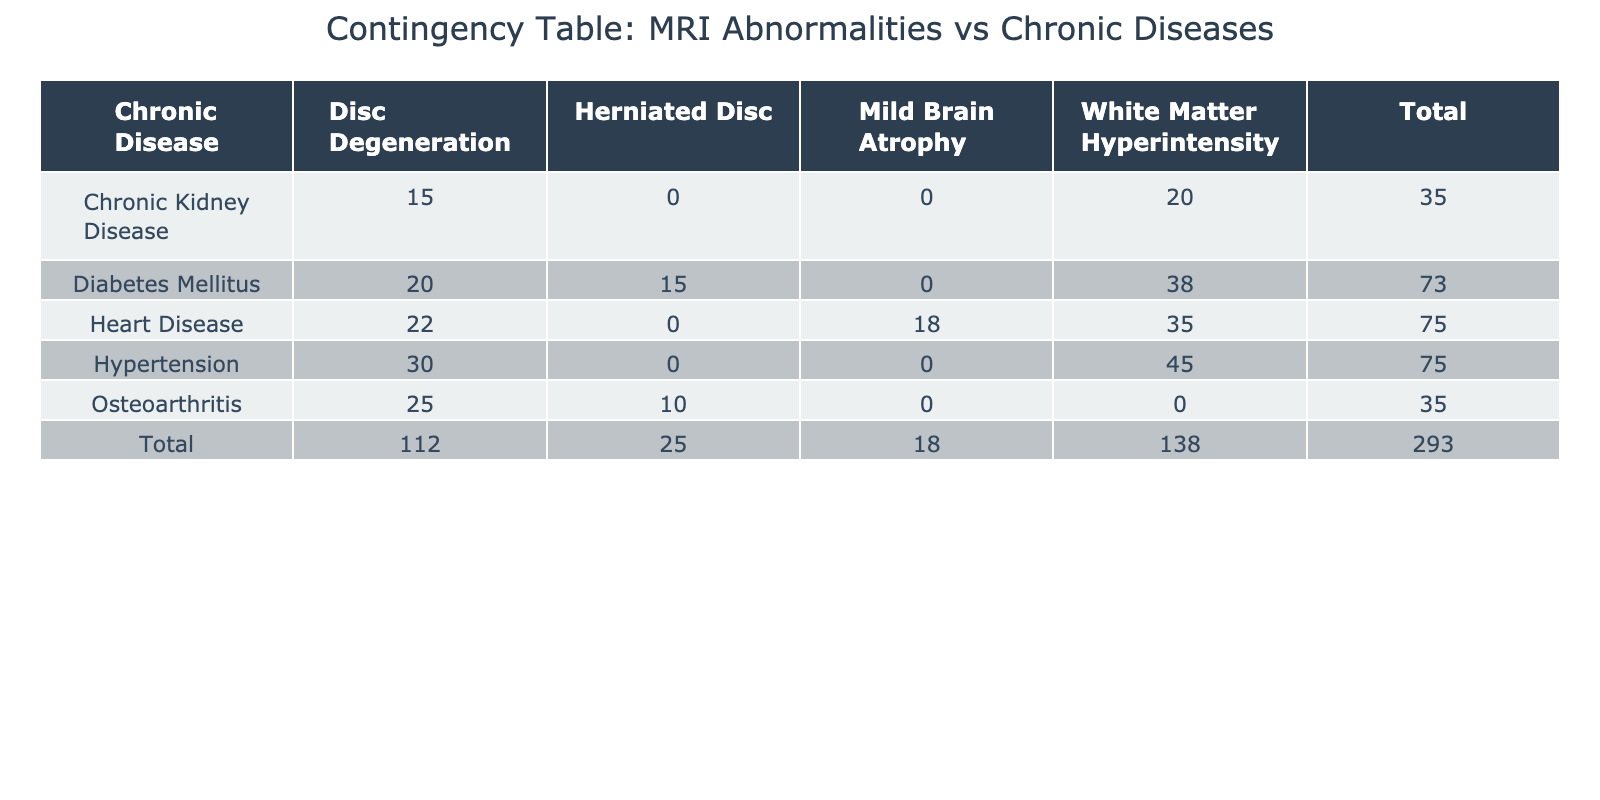What is the total count of MRI abnormalities for patients with Diabetes Mellitus? To get the total count of MRI abnormalities for Diabetes Mellitus, we check the row corresponding to this chronic disease and sum the values across all MRI abnormalities listed: 38 (White Matter Hyperintensity) + 20 (Disc Degeneration) + 15 (Herniated Disc) = 73.
Answer: 73 Which chronic disease shows the highest count of MRI abnormalities? Looking at the totals at the end of each row, we compare the total counts for each chronic disease. Hypertension has 75 (45 + 30), Diabetes Mellitus has 73 (38 + 20 + 15), Osteoarthritis has 35 (25 + 10), Chronic Kidney Disease has 35 (20 + 15), and Heart Disease has 75 (35 + 18 + 22). Since both Hypertension and Heart Disease have the highest total of 75, we conclude that they share this distinction.
Answer: Hypertension and Heart Disease Is there a chronic disease with no recorded cases of Herniated Disc abnormalities? We inspect the table for the presence of Herniated Disc counts in each chronic disease. We see that neither Hypertension nor Osteoarthritis has a record of Herniated Disc abnormalities (0). Thus, both can be considered as having no recorded cases.
Answer: Yes, Osteoarthritis What is the difference in counts between White Matter Hyperintensity and Disc Degeneration for Heart Disease? For Heart Disease, the count of White Matter Hyperintensity is 35 and the count of Disc Degeneration is 22. To find the difference, we subtract the two counts: 35 - 22 = 13.
Answer: 13 How many abnormalities were observed for patients with Chronic Kidney Disease in total? The total count for Chronic Kidney Disease can be found by adding all the relevant counts from that row: 20 (White Matter Hyperintensity) + 15 (Disc Degeneration) = 35.
Answer: 35 Is the count of Disc Degeneration for Osteoarthritis higher than the count of Herniated Disc for the same chronic disease? For Osteoarthritis, the count of Disc Degeneration is 25 and the count of Herniated Disc is 10. 25 is indeed greater than 10, so the answer is yes.
Answer: Yes What is the combined total of White Matter Hyperintensity across all chronic diseases? We need to add the counts of White Matter Hyperintensity for each chronic disease: 45 (Hypertension) + 38 (Diabetes Mellitus) + 20 (Chronic Kidney Disease) + 35 (Heart Disease) = 138.
Answer: 138 Which chronic disease has the lowest total count of MRI abnormalities? By inspecting the row totals, we find that Osteoarthritis and Chronic Kidney Disease both have a total count of 35, which is the lowest among all chronic diseases.
Answer: Osteoarthritis and Chronic Kidney Disease 